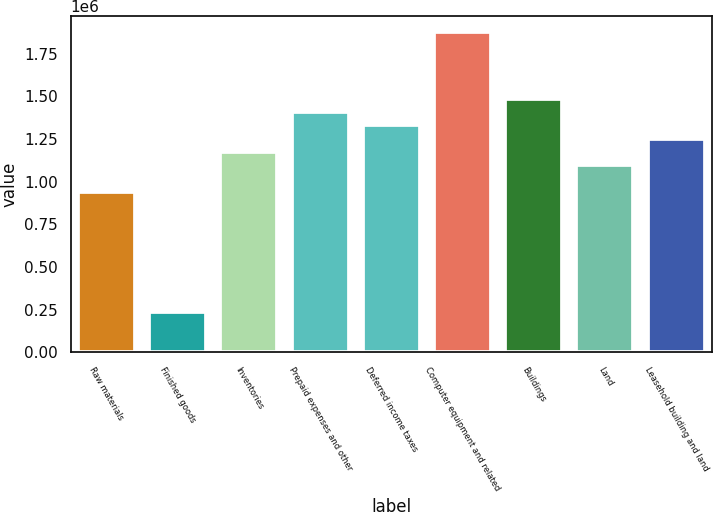Convert chart to OTSL. <chart><loc_0><loc_0><loc_500><loc_500><bar_chart><fcel>Raw materials<fcel>Finished goods<fcel>Inventories<fcel>Prepaid expenses and other<fcel>Deferred income taxes<fcel>Computer equipment and related<fcel>Buildings<fcel>Land<fcel>Leasehold building and land<nl><fcel>939070<fcel>235240<fcel>1.17368e+06<fcel>1.40829e+06<fcel>1.33009e+06<fcel>1.87751e+06<fcel>1.48649e+06<fcel>1.09548e+06<fcel>1.25188e+06<nl></chart> 